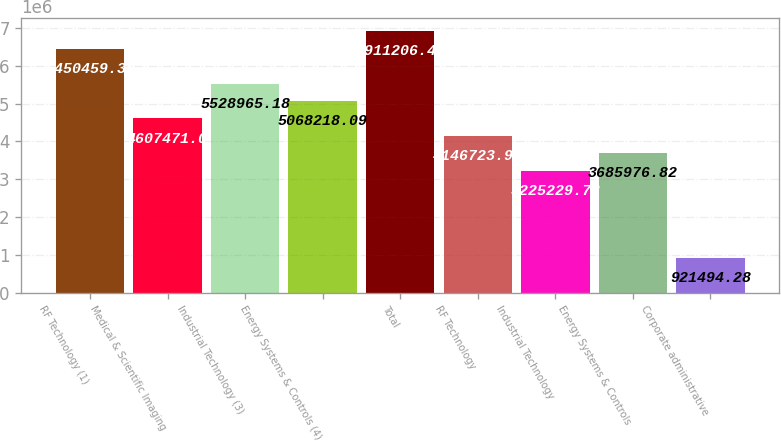<chart> <loc_0><loc_0><loc_500><loc_500><bar_chart><fcel>RF Technology (1)<fcel>Medical & Scientific Imaging<fcel>Industrial Technology (3)<fcel>Energy Systems & Controls (4)<fcel>Total<fcel>RF Technology<fcel>Industrial Technology<fcel>Energy Systems & Controls<fcel>Corporate administrative<nl><fcel>6.45046e+06<fcel>4.60747e+06<fcel>5.52897e+06<fcel>5.06822e+06<fcel>6.91121e+06<fcel>4.14672e+06<fcel>3.22523e+06<fcel>3.68598e+06<fcel>921494<nl></chart> 